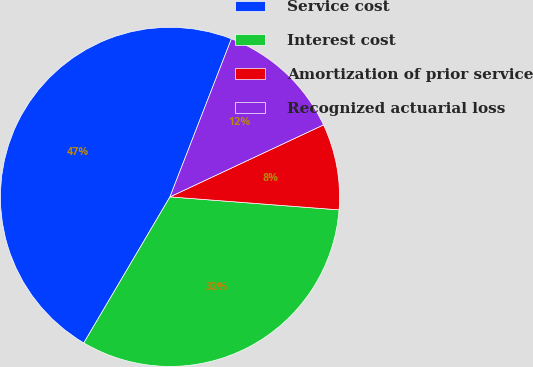<chart> <loc_0><loc_0><loc_500><loc_500><pie_chart><fcel>Service cost<fcel>Interest cost<fcel>Amortization of prior service<fcel>Recognized actuarial loss<nl><fcel>47.42%<fcel>32.26%<fcel>8.2%<fcel>12.12%<nl></chart> 